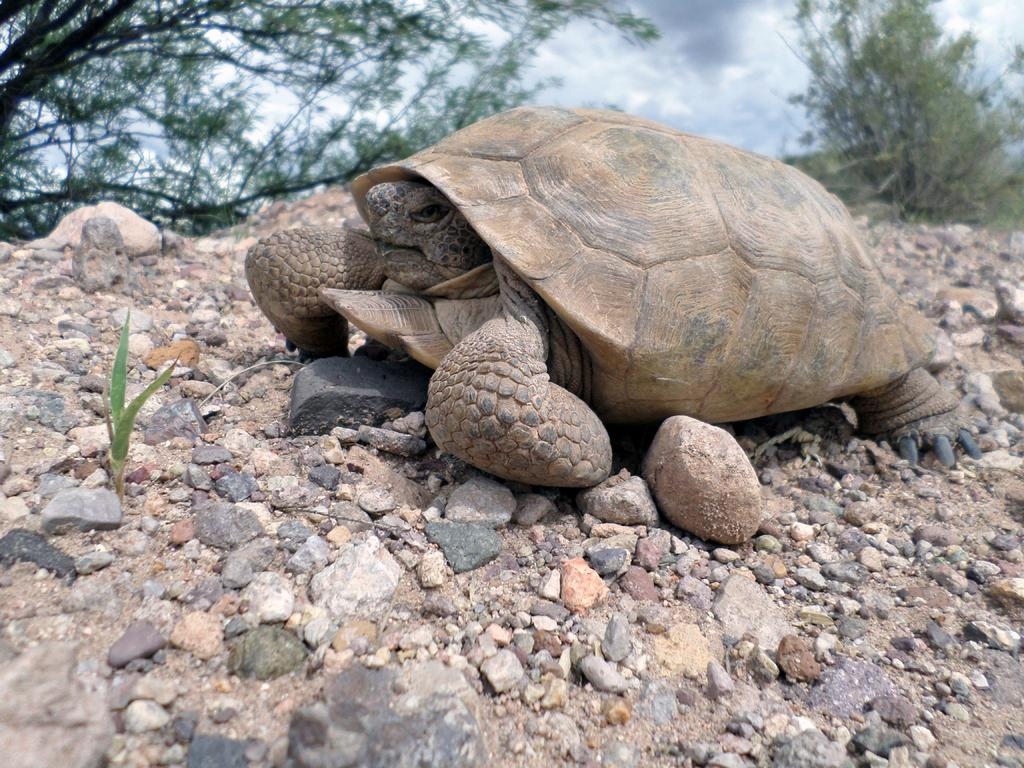What type of animal is on the ground in the image? There is a tortoise on the ground in the image. What else can be seen on the ground besides the tortoise? There are rocks on the ground in the image. What type of vegetation is present in the image? There is a plant and trees in the image, as well as grass on the ground. How would you describe the sky in the background of the image? The sky is visible in the background of the image, and it appears to be cloudy. What type of argument is the tortoise having with the leaf in the image? There is no leaf present in the image, and therefore no argument can be observed. 